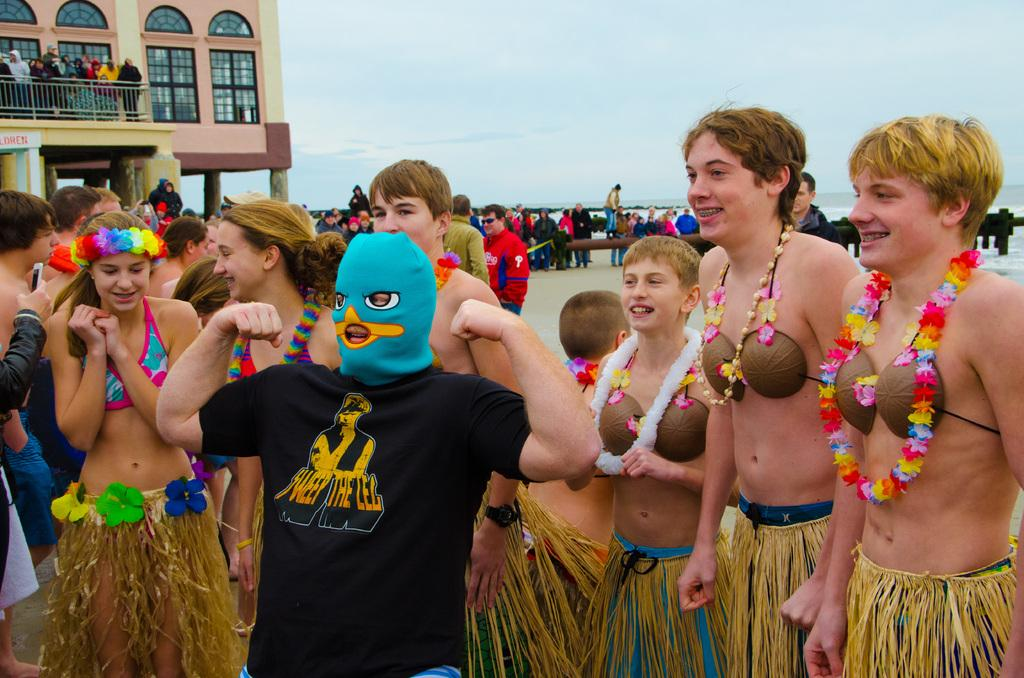How many people are in the image? There is a group of people standing in the image, but the exact number cannot be determined from the provided facts. What can be seen in the background of the image? There is a building, water, and the sky visible in the background of the image. What type of brick is being used to plough the field in the image? There is no brick or plough present in the image; it features a group of people and a background with a building, water, and sky. 